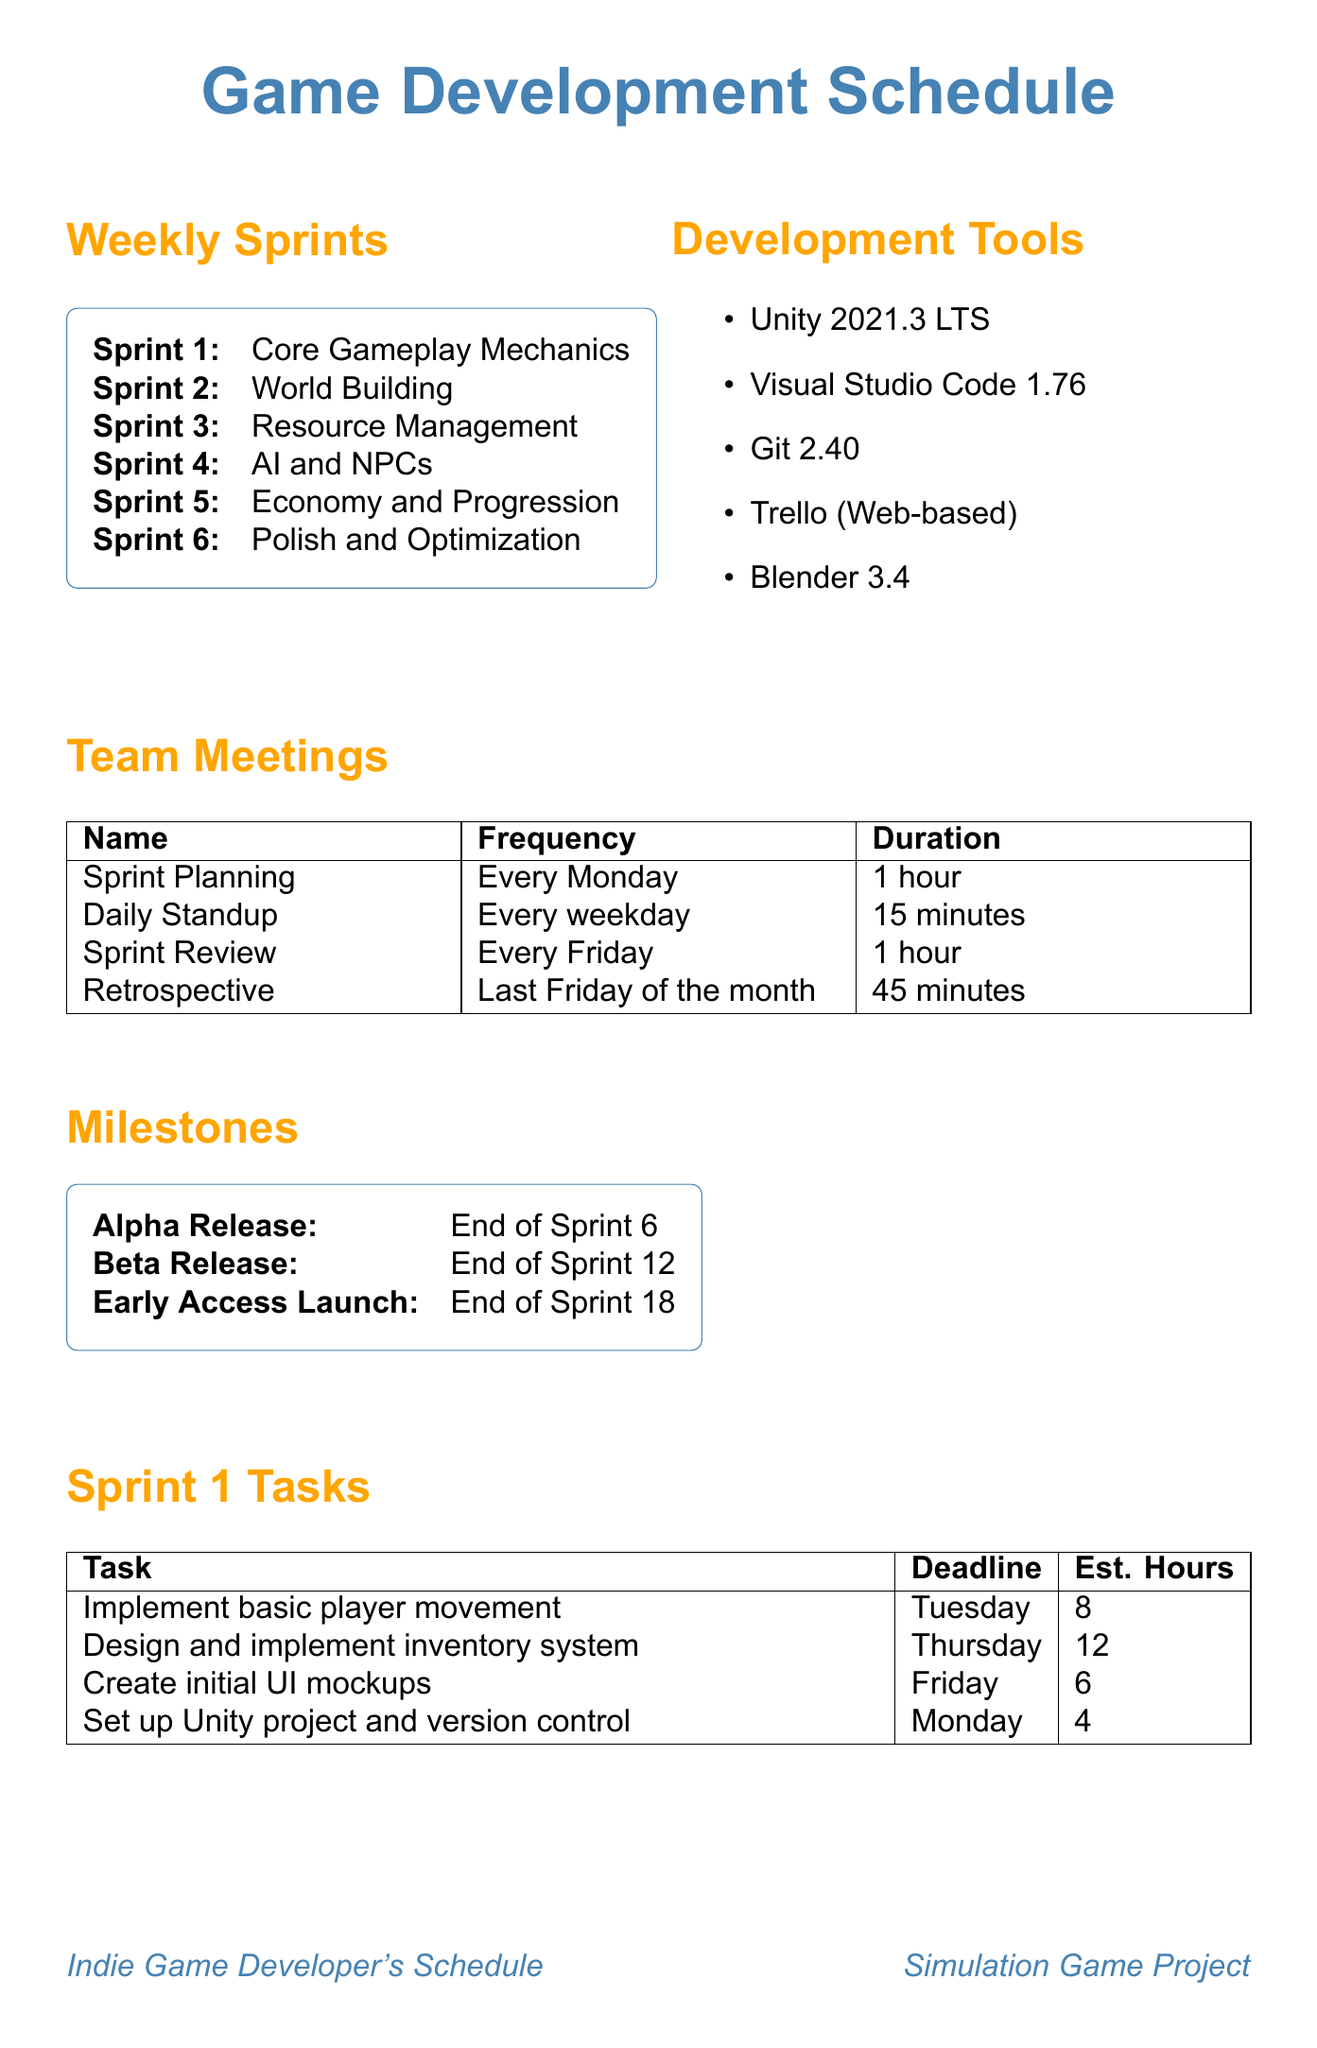what is the focus of Sprint 2? The focus of Sprint 2 is explicitly stated in the document.
Answer: World Building how many estimated hours for creating initial UI mockups in Sprint 1? The estimated hours for creating initial UI mockups is found in the list of tasks for Sprint 1.
Answer: 6 on which day is the Sprint Review meeting held? The document indicates the frequency of the Sprint Review meeting.
Answer: Every Friday what is the target date for the Beta Release milestone? The target date for the Beta Release is mentioned in the milestones section.
Answer: End of Sprint 12 which development tool is used for code editing? The specific tool used for code editing is detailed in the section on development tools.
Answer: Visual Studio Code how many tasks are listed for Sprint 3? The tasks for each sprint are itemized in the document, and the total for Sprint 3 can be calculated.
Answer: 4 which Sprint focuses on AI and NPCs? Each sprint has a designated focus, and this one can be directly retrieved from the document.
Answer: Sprint 4 what is the duration of the Daily Standup meeting? The duration of the Daily Standup meeting is mentioned in the team meetings section.
Answer: 15 minutes which task in Sprint 5 has a deadline on Thursday? The tasks in Sprint 5 are listed with their deadlines, revealing which aligns with Thursday.
Answer: Design and create skill progression system 